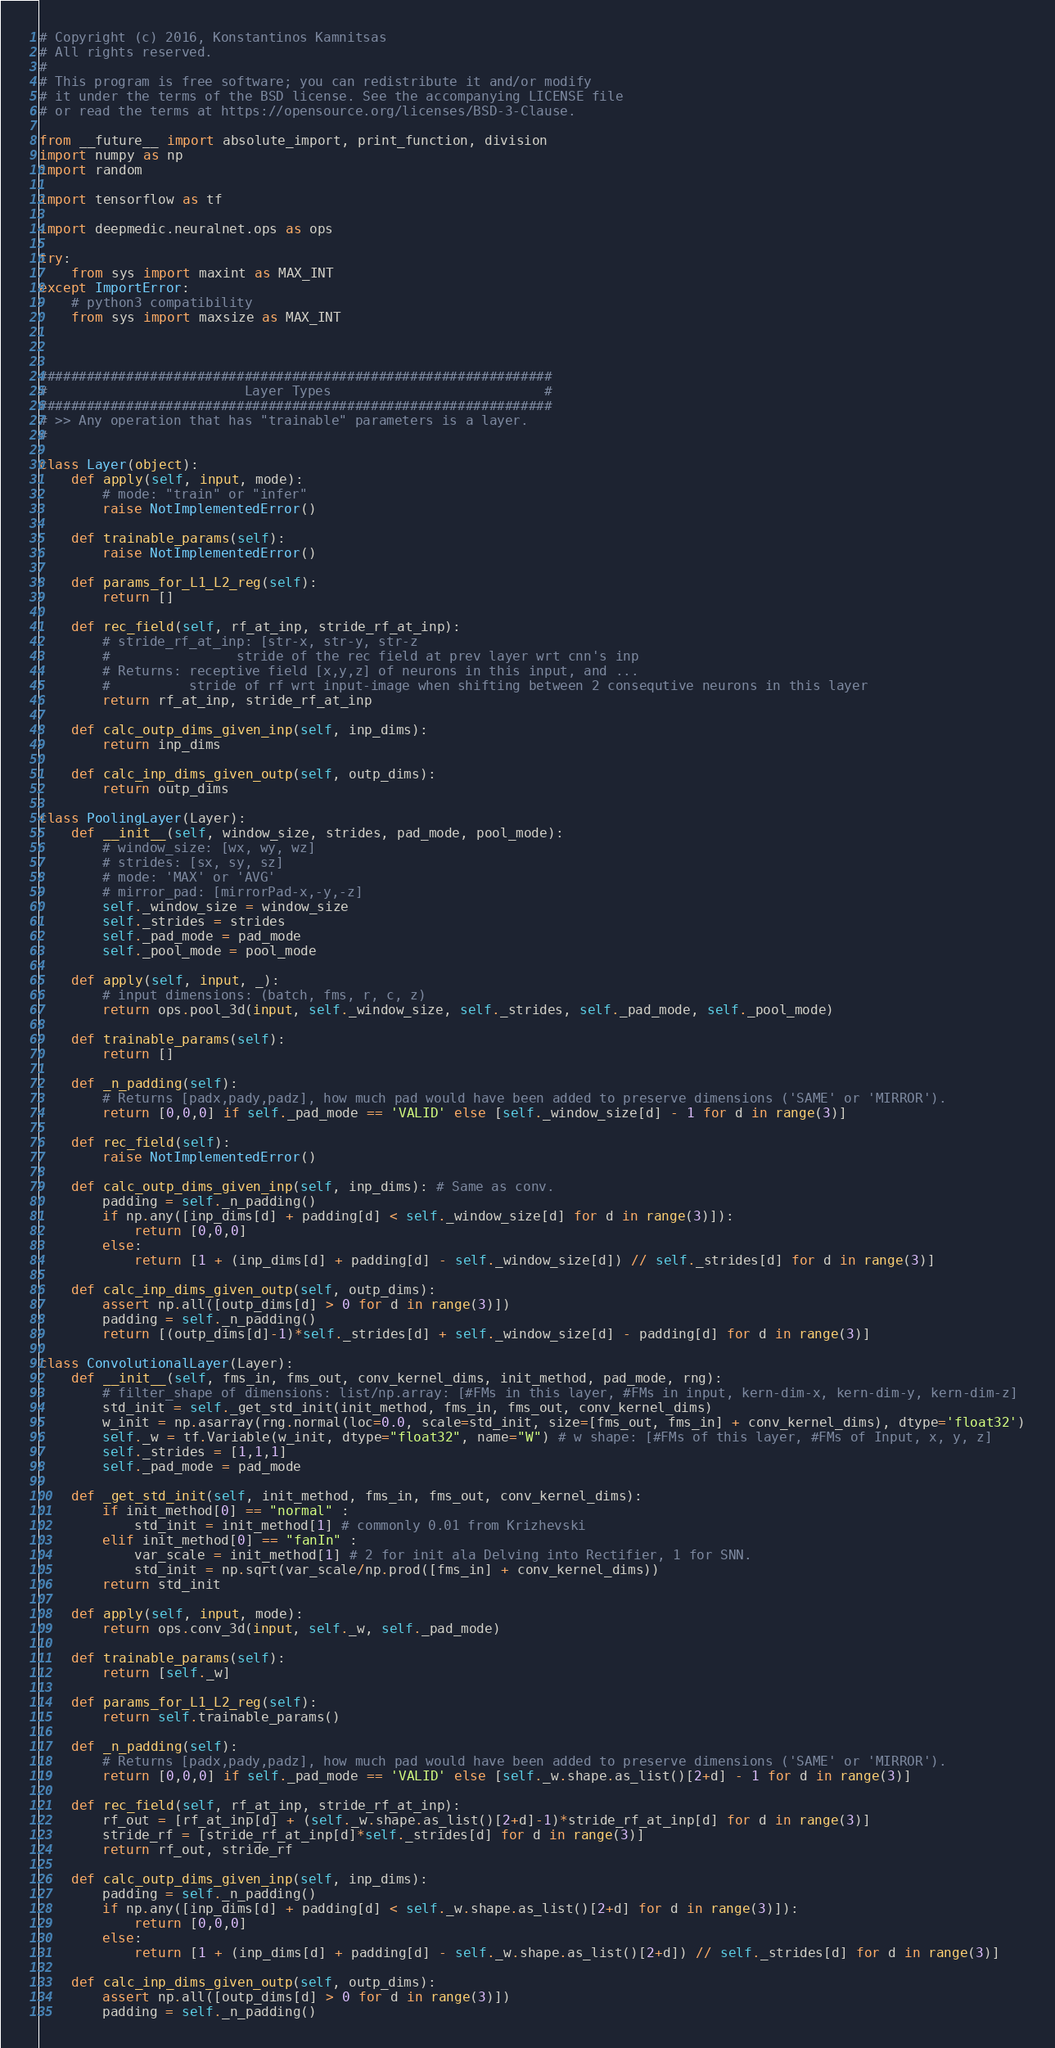<code> <loc_0><loc_0><loc_500><loc_500><_Python_># Copyright (c) 2016, Konstantinos Kamnitsas
# All rights reserved.
#
# This program is free software; you can redistribute it and/or modify
# it under the terms of the BSD license. See the accompanying LICENSE file
# or read the terms at https://opensource.org/licenses/BSD-3-Clause.

from __future__ import absolute_import, print_function, division
import numpy as np
import random

import tensorflow as tf

import deepmedic.neuralnet.ops as ops

try:
    from sys import maxint as MAX_INT
except ImportError:
    # python3 compatibility
    from sys import maxsize as MAX_INT

        

#################################################################
#                         Layer Types                           #
#################################################################
# >> Any operation that has "trainable" parameters is a layer. 
#

class Layer(object):
    def apply(self, input, mode):
        # mode: "train" or "infer"
        raise NotImplementedError()
    
    def trainable_params(self):
        raise NotImplementedError()
    
    def params_for_L1_L2_reg(self):
        return []
    
    def rec_field(self, rf_at_inp, stride_rf_at_inp):
        # stride_rf_at_inp: [str-x, str-y, str-z
        #                stride of the rec field at prev layer wrt cnn's inp
        # Returns: receptive field [x,y,z] of neurons in this input, and ...
        #          stride of rf wrt input-image when shifting between 2 consequtive neurons in this layer
        return rf_at_inp, stride_rf_at_inp
    
    def calc_outp_dims_given_inp(self, inp_dims):
        return inp_dims
    
    def calc_inp_dims_given_outp(self, outp_dims):
        return outp_dims
    
class PoolingLayer(Layer):
    def __init__(self, window_size, strides, pad_mode, pool_mode):
        # window_size: [wx, wy, wz]
        # strides: [sx, sy, sz]
        # mode: 'MAX' or 'AVG'
        # mirror_pad: [mirrorPad-x,-y,-z]
        self._window_size = window_size
        self._strides = strides
        self._pad_mode = pad_mode
        self._pool_mode = pool_mode
        
    def apply(self, input, _):
        # input dimensions: (batch, fms, r, c, z)
        return ops.pool_3d(input, self._window_size, self._strides, self._pad_mode, self._pool_mode)
        
    def trainable_params(self):
        return []
    
    def _n_padding(self):
        # Returns [padx,pady,padz], how much pad would have been added to preserve dimensions ('SAME' or 'MIRROR').
        return [0,0,0] if self._pad_mode == 'VALID' else [self._window_size[d] - 1 for d in range(3)]
    
    def rec_field(self):
        raise NotImplementedError()
    
    def calc_outp_dims_given_inp(self, inp_dims): # Same as conv.
        padding = self._n_padding()
        if np.any([inp_dims[d] + padding[d] < self._window_size[d] for d in range(3)]):
            return [0,0,0]
        else:
            return [1 + (inp_dims[d] + padding[d] - self._window_size[d]) // self._strides[d] for d in range(3)]
    
    def calc_inp_dims_given_outp(self, outp_dims):
        assert np.all([outp_dims[d] > 0 for d in range(3)])
        padding = self._n_padding()
        return [(outp_dims[d]-1)*self._strides[d] + self._window_size[d] - padding[d] for d in range(3)]
    
class ConvolutionalLayer(Layer):
    def __init__(self, fms_in, fms_out, conv_kernel_dims, init_method, pad_mode, rng):
        # filter_shape of dimensions: list/np.array: [#FMs in this layer, #FMs in input, kern-dim-x, kern-dim-y, kern-dim-z]
        std_init = self._get_std_init(init_method, fms_in, fms_out, conv_kernel_dims)
        w_init = np.asarray(rng.normal(loc=0.0, scale=std_init, size=[fms_out, fms_in] + conv_kernel_dims), dtype='float32')
        self._w = tf.Variable(w_init, dtype="float32", name="W") # w shape: [#FMs of this layer, #FMs of Input, x, y, z]
        self._strides = [1,1,1]
        self._pad_mode = pad_mode
        
    def _get_std_init(self, init_method, fms_in, fms_out, conv_kernel_dims):
        if init_method[0] == "normal" :
            std_init = init_method[1] # commonly 0.01 from Krizhevski
        elif init_method[0] == "fanIn" :
            var_scale = init_method[1] # 2 for init ala Delving into Rectifier, 1 for SNN.
            std_init = np.sqrt(var_scale/np.prod([fms_in] + conv_kernel_dims))
        return std_init
    
    def apply(self, input, mode):
        return ops.conv_3d(input, self._w, self._pad_mode)

    def trainable_params(self):
        return [self._w]
    
    def params_for_L1_L2_reg(self):
        return self.trainable_params()
    
    def _n_padding(self):
        # Returns [padx,pady,padz], how much pad would have been added to preserve dimensions ('SAME' or 'MIRROR').
        return [0,0,0] if self._pad_mode == 'VALID' else [self._w.shape.as_list()[2+d] - 1 for d in range(3)]
    
    def rec_field(self, rf_at_inp, stride_rf_at_inp):
        rf_out = [rf_at_inp[d] + (self._w.shape.as_list()[2+d]-1)*stride_rf_at_inp[d] for d in range(3)]
        stride_rf = [stride_rf_at_inp[d]*self._strides[d] for d in range(3)]
        return rf_out, stride_rf
    
    def calc_outp_dims_given_inp(self, inp_dims):
        padding = self._n_padding()
        if np.any([inp_dims[d] + padding[d] < self._w.shape.as_list()[2+d] for d in range(3)]):
            return [0,0,0]
        else:
            return [1 + (inp_dims[d] + padding[d] - self._w.shape.as_list()[2+d]) // self._strides[d] for d in range(3)]
    
    def calc_inp_dims_given_outp(self, outp_dims):
        assert np.all([outp_dims[d] > 0 for d in range(3)])
        padding = self._n_padding()</code> 